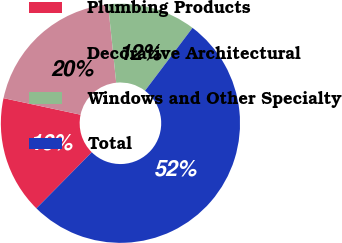Convert chart. <chart><loc_0><loc_0><loc_500><loc_500><pie_chart><fcel>Plumbing Products<fcel>Decorative Architectural<fcel>Windows and Other Specialty<fcel>Total<nl><fcel>15.97%<fcel>19.98%<fcel>11.95%<fcel>52.1%<nl></chart> 